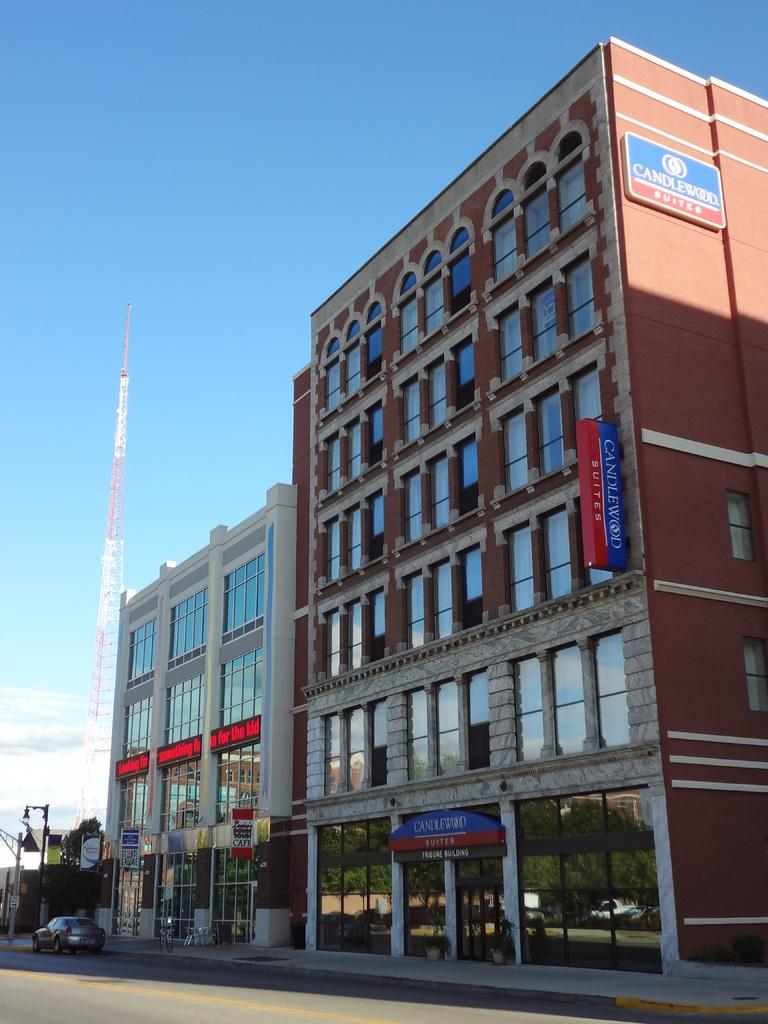What type of structure is present in the image? There is a building in the image. What colors are used for the building? The building is in blue and white color. What can be seen in the background of the image? There is a vehicle and trees in the background of the image, and the trees are green. What is visible in the sky in the image? The sky is visible in the background of the image, and it is blue and white color. What type of development is taking place at the camp in the image? There is no camp or development present in the image; it features a building, vehicle, trees, and sky. What type of brick is used for the construction of the building in the image? There is no information about the type of brick used for the construction of the building in the image. 